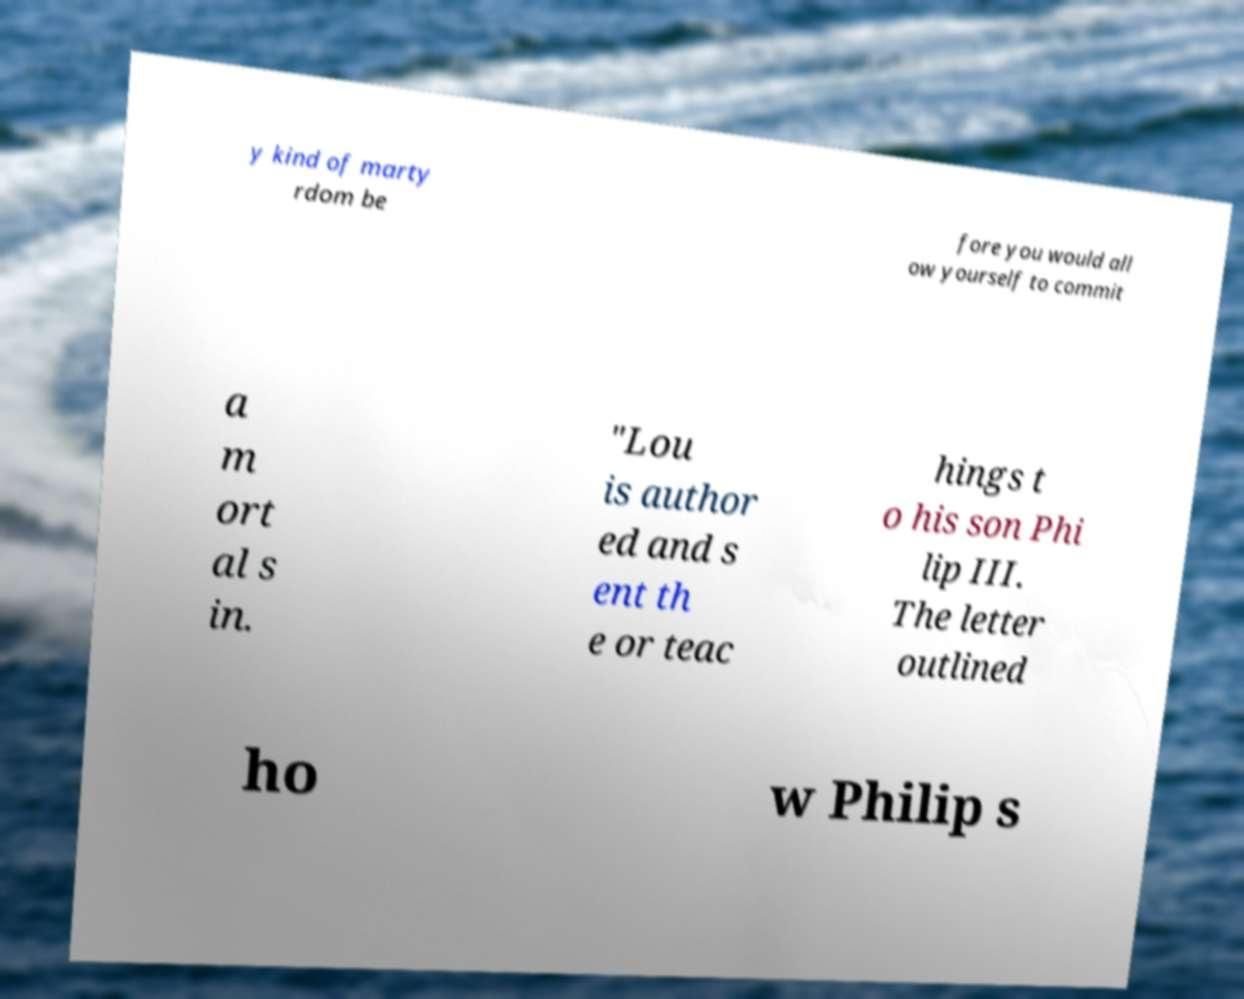Could you assist in decoding the text presented in this image and type it out clearly? y kind of marty rdom be fore you would all ow yourself to commit a m ort al s in. "Lou is author ed and s ent th e or teac hings t o his son Phi lip III. The letter outlined ho w Philip s 